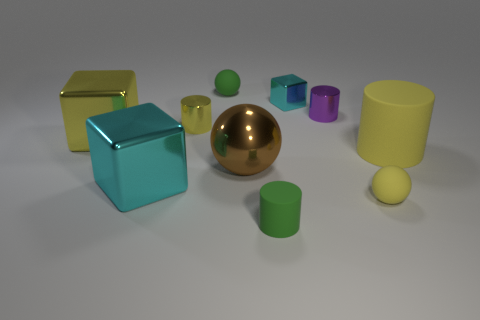Subtract all cylinders. How many objects are left? 6 Add 7 brown balls. How many brown balls exist? 8 Subtract 0 red spheres. How many objects are left? 10 Subtract all purple metallic cylinders. Subtract all large cyan metallic blocks. How many objects are left? 8 Add 5 purple metal things. How many purple metal things are left? 6 